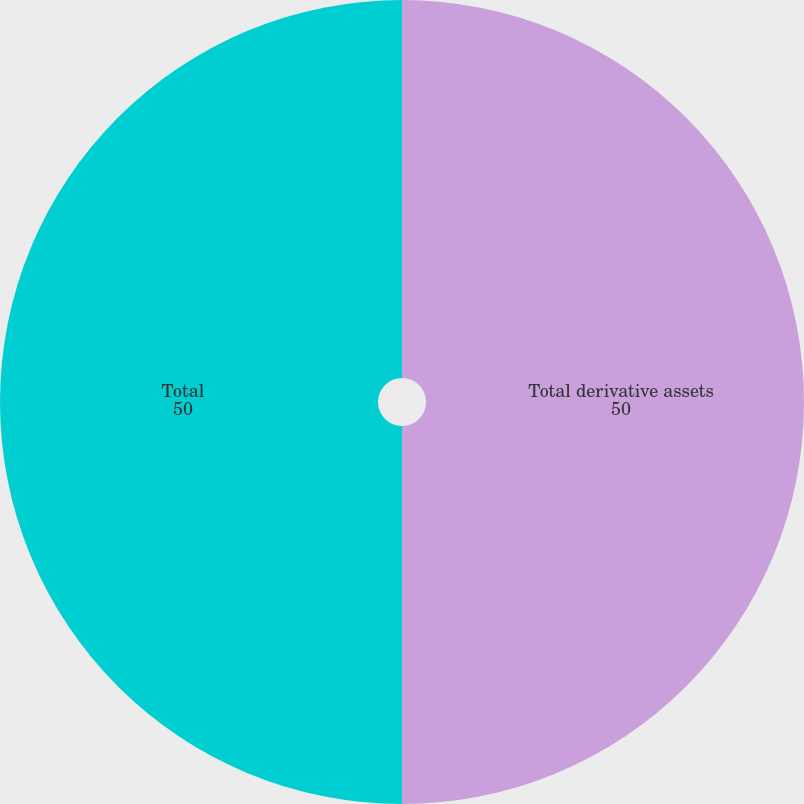<chart> <loc_0><loc_0><loc_500><loc_500><pie_chart><fcel>Total derivative assets<fcel>Total<nl><fcel>50.0%<fcel>50.0%<nl></chart> 